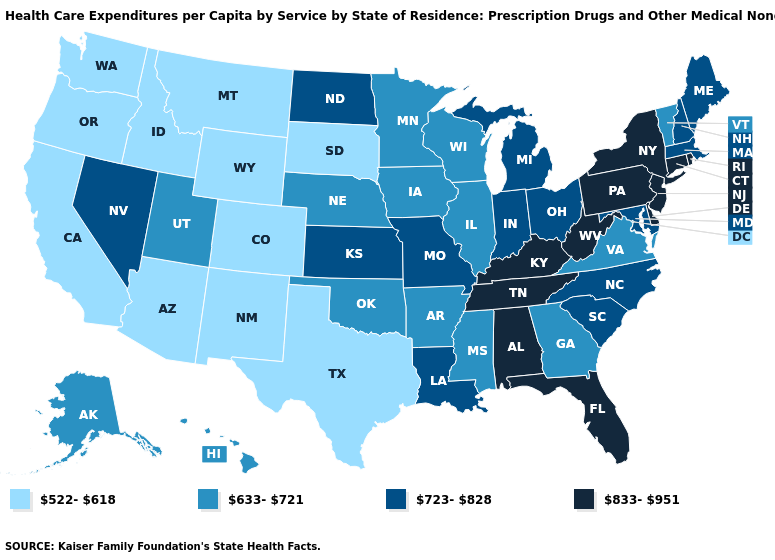How many symbols are there in the legend?
Quick response, please. 4. Name the states that have a value in the range 522-618?
Give a very brief answer. Arizona, California, Colorado, Idaho, Montana, New Mexico, Oregon, South Dakota, Texas, Washington, Wyoming. Is the legend a continuous bar?
Write a very short answer. No. What is the value of Michigan?
Write a very short answer. 723-828. Among the states that border Georgia , which have the lowest value?
Be succinct. North Carolina, South Carolina. Among the states that border Idaho , which have the lowest value?
Write a very short answer. Montana, Oregon, Washington, Wyoming. Which states have the highest value in the USA?
Quick response, please. Alabama, Connecticut, Delaware, Florida, Kentucky, New Jersey, New York, Pennsylvania, Rhode Island, Tennessee, West Virginia. What is the value of Wisconsin?
Keep it brief. 633-721. Name the states that have a value in the range 633-721?
Be succinct. Alaska, Arkansas, Georgia, Hawaii, Illinois, Iowa, Minnesota, Mississippi, Nebraska, Oklahoma, Utah, Vermont, Virginia, Wisconsin. What is the value of South Dakota?
Quick response, please. 522-618. Does Nevada have a higher value than North Dakota?
Concise answer only. No. Among the states that border Utah , does Nevada have the lowest value?
Keep it brief. No. Does Pennsylvania have a higher value than New Hampshire?
Concise answer only. Yes. Does South Dakota have a higher value than Idaho?
Short answer required. No. What is the value of Wyoming?
Quick response, please. 522-618. 